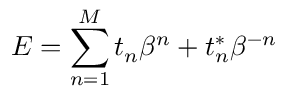<formula> <loc_0><loc_0><loc_500><loc_500>E = \sum _ { n = 1 } ^ { M } t _ { n } \beta ^ { n } + t _ { n } ^ { \ast } \beta ^ { - n }</formula> 